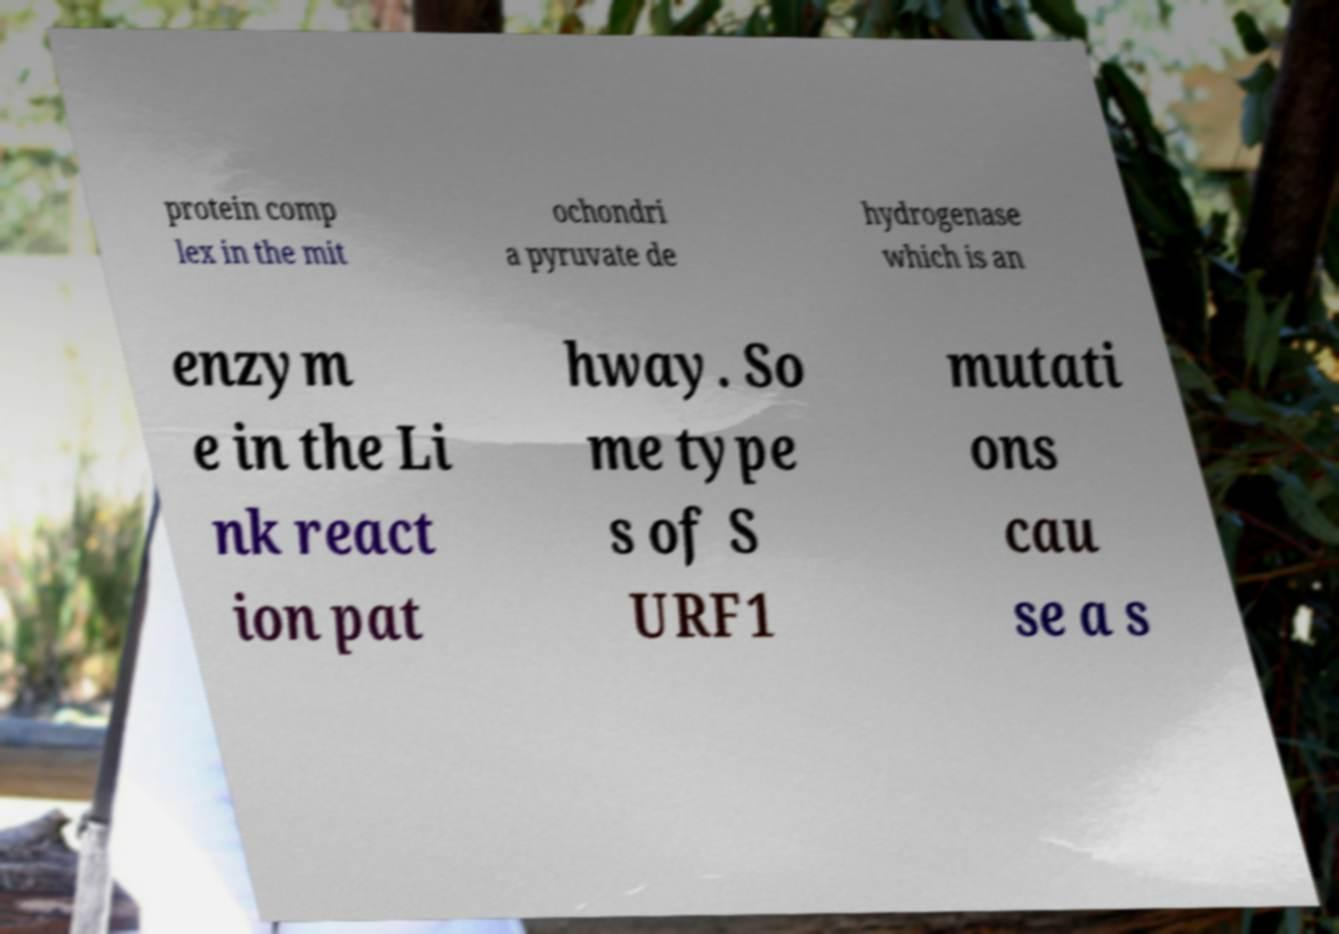Can you read and provide the text displayed in the image?This photo seems to have some interesting text. Can you extract and type it out for me? protein comp lex in the mit ochondri a pyruvate de hydrogenase which is an enzym e in the Li nk react ion pat hway. So me type s of S URF1 mutati ons cau se a s 